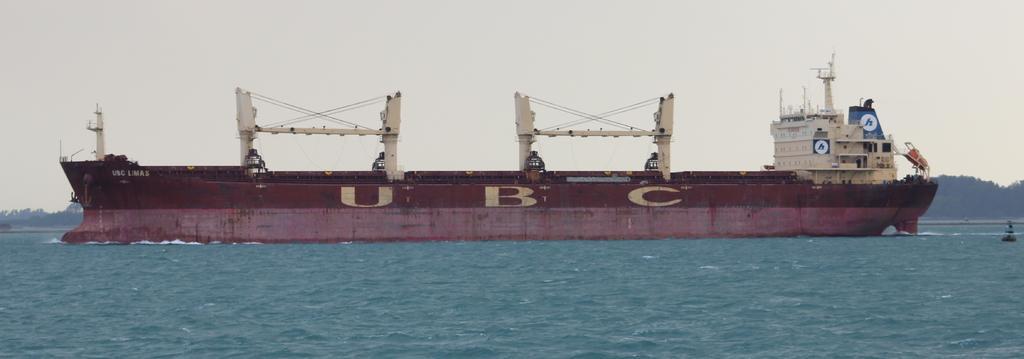In one or two sentences, can you explain what this image depicts? In this picture we can see a ship on the water, some objects and in the background we can see trees and the sky. 